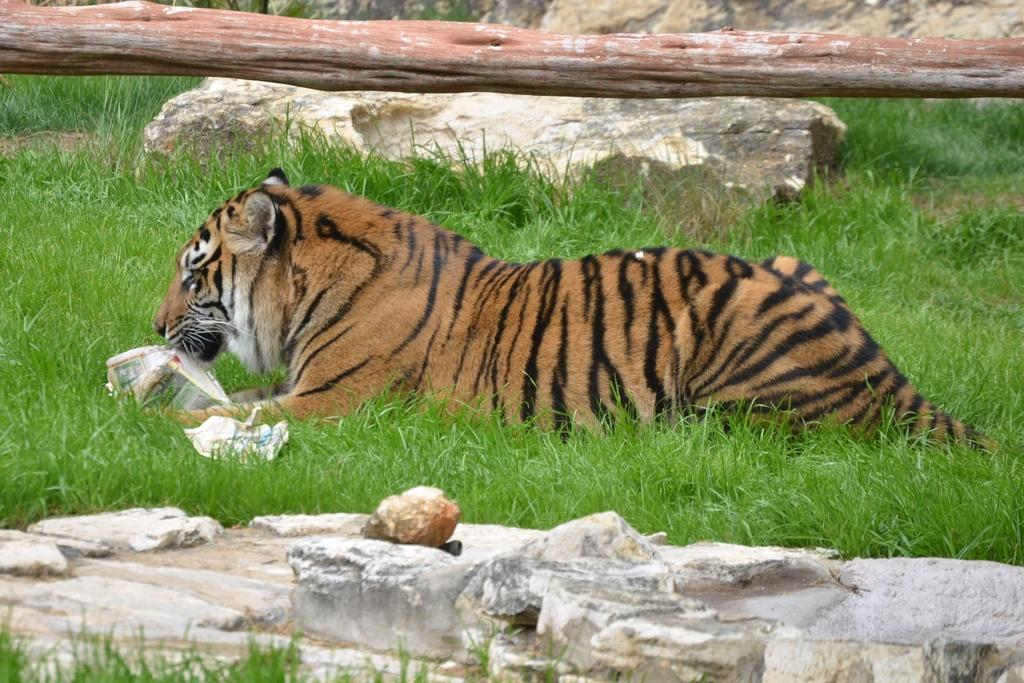What animal is the main subject of the image? There is a tiger in the image. What is the tiger interacting with in the image? There is an object with the tiger. What type of terrain is visible in the image? The ground is visible in the image, and it has grass and stones on it. What type of plant is partially visible in the image? The trunk of a tree is visible in the image. What word does the tiger use to communicate with the farmer in the image? There is no farmer present in the image, and tigers do not use words to communicate. 